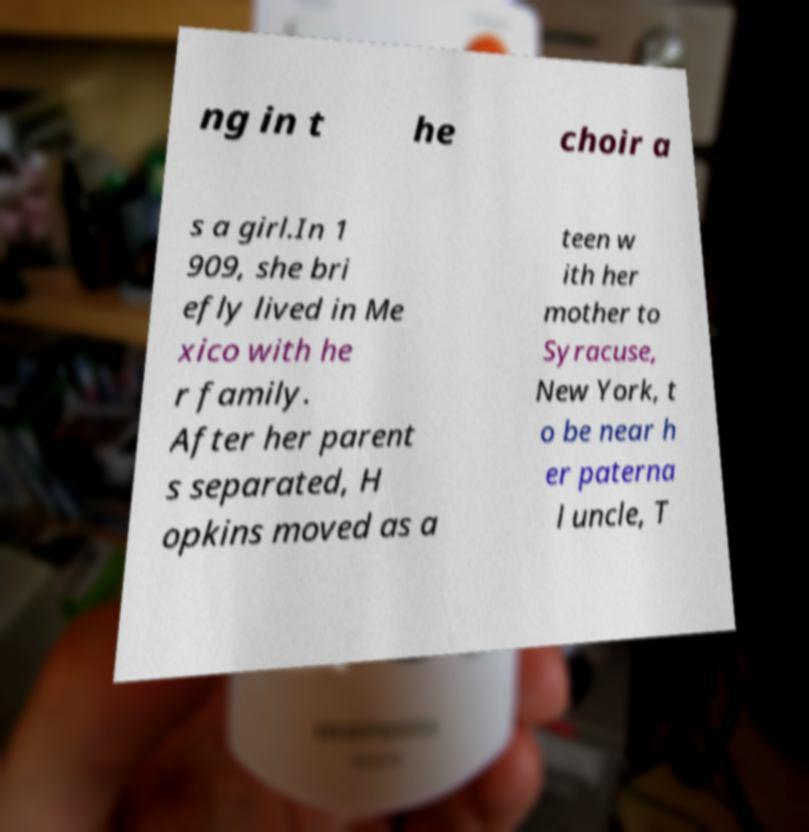What messages or text are displayed in this image? I need them in a readable, typed format. ng in t he choir a s a girl.In 1 909, she bri efly lived in Me xico with he r family. After her parent s separated, H opkins moved as a teen w ith her mother to Syracuse, New York, t o be near h er paterna l uncle, T 